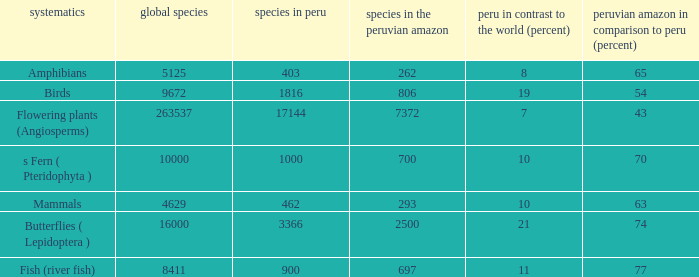What's the total number of species in the peruvian amazon with 8411 species in the world  1.0. 